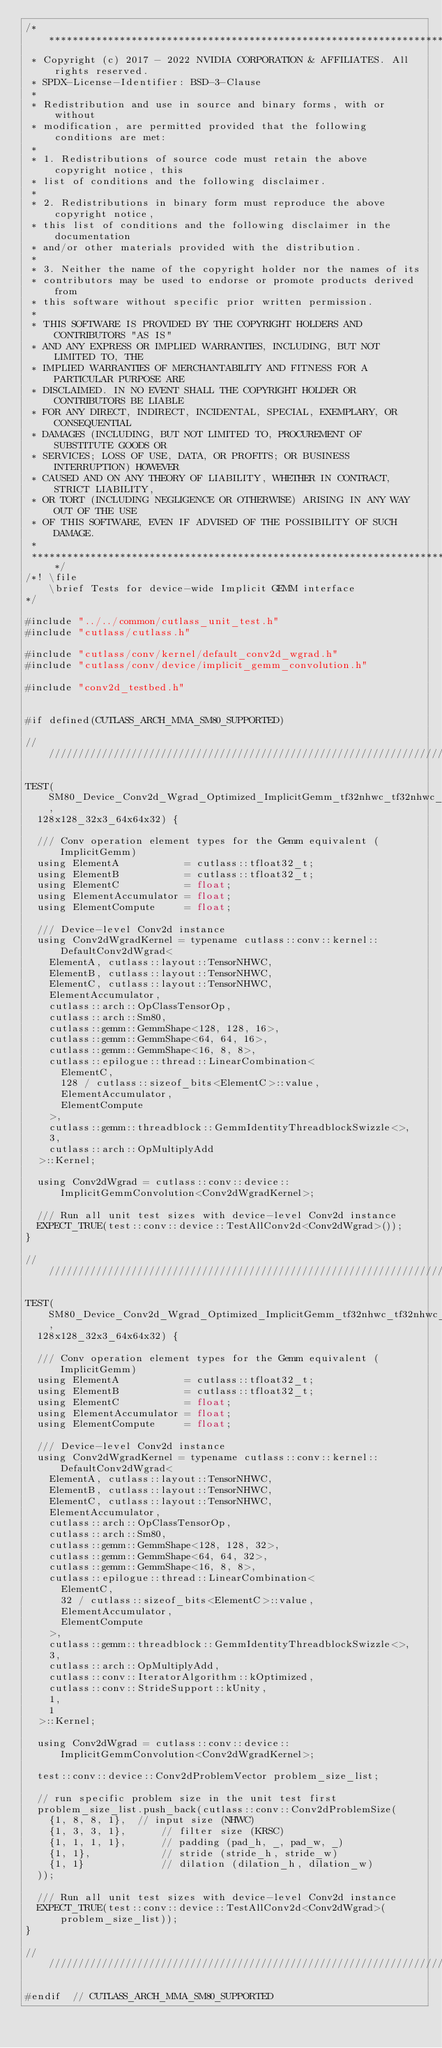Convert code to text. <code><loc_0><loc_0><loc_500><loc_500><_Cuda_>/***************************************************************************************************
 * Copyright (c) 2017 - 2022 NVIDIA CORPORATION & AFFILIATES. All rights reserved.
 * SPDX-License-Identifier: BSD-3-Clause
 *
 * Redistribution and use in source and binary forms, with or without
 * modification, are permitted provided that the following conditions are met:
 *
 * 1. Redistributions of source code must retain the above copyright notice, this
 * list of conditions and the following disclaimer.
 *
 * 2. Redistributions in binary form must reproduce the above copyright notice,
 * this list of conditions and the following disclaimer in the documentation
 * and/or other materials provided with the distribution.
 *
 * 3. Neither the name of the copyright holder nor the names of its
 * contributors may be used to endorse or promote products derived from
 * this software without specific prior written permission.
 *
 * THIS SOFTWARE IS PROVIDED BY THE COPYRIGHT HOLDERS AND CONTRIBUTORS "AS IS"
 * AND ANY EXPRESS OR IMPLIED WARRANTIES, INCLUDING, BUT NOT LIMITED TO, THE
 * IMPLIED WARRANTIES OF MERCHANTABILITY AND FITNESS FOR A PARTICULAR PURPOSE ARE
 * DISCLAIMED. IN NO EVENT SHALL THE COPYRIGHT HOLDER OR CONTRIBUTORS BE LIABLE
 * FOR ANY DIRECT, INDIRECT, INCIDENTAL, SPECIAL, EXEMPLARY, OR CONSEQUENTIAL
 * DAMAGES (INCLUDING, BUT NOT LIMITED TO, PROCUREMENT OF SUBSTITUTE GOODS OR
 * SERVICES; LOSS OF USE, DATA, OR PROFITS; OR BUSINESS INTERRUPTION) HOWEVER
 * CAUSED AND ON ANY THEORY OF LIABILITY, WHETHER IN CONTRACT, STRICT LIABILITY,
 * OR TORT (INCLUDING NEGLIGENCE OR OTHERWISE) ARISING IN ANY WAY OUT OF THE USE
 * OF THIS SOFTWARE, EVEN IF ADVISED OF THE POSSIBILITY OF SUCH DAMAGE.
 *
 **************************************************************************************************/
/*! \file
    \brief Tests for device-wide Implicit GEMM interface
*/

#include "../../common/cutlass_unit_test.h"
#include "cutlass/cutlass.h"

#include "cutlass/conv/kernel/default_conv2d_wgrad.h"
#include "cutlass/conv/device/implicit_gemm_convolution.h"

#include "conv2d_testbed.h"


#if defined(CUTLASS_ARCH_MMA_SM80_SUPPORTED)

////////////////////////////////////////////////////////////////////////////////

TEST(SM80_Device_Conv2d_Wgrad_Optimized_ImplicitGemm_tf32nhwc_tf32nhwc_f32nhwc_tensor_op_f32,
  128x128_32x3_64x64x32) {

  /// Conv operation element types for the Gemm equivalent (ImplicitGemm)
  using ElementA           = cutlass::tfloat32_t;
  using ElementB           = cutlass::tfloat32_t;
  using ElementC           = float;
  using ElementAccumulator = float;
  using ElementCompute     = float;

  /// Device-level Conv2d instance
  using Conv2dWgradKernel = typename cutlass::conv::kernel::DefaultConv2dWgrad<
    ElementA, cutlass::layout::TensorNHWC,
    ElementB, cutlass::layout::TensorNHWC,
    ElementC, cutlass::layout::TensorNHWC,
    ElementAccumulator,
    cutlass::arch::OpClassTensorOp,
    cutlass::arch::Sm80,
    cutlass::gemm::GemmShape<128, 128, 16>,
    cutlass::gemm::GemmShape<64, 64, 16>,
    cutlass::gemm::GemmShape<16, 8, 8>,
    cutlass::epilogue::thread::LinearCombination<
      ElementC,
      128 / cutlass::sizeof_bits<ElementC>::value,
      ElementAccumulator,
      ElementCompute
    >,
    cutlass::gemm::threadblock::GemmIdentityThreadblockSwizzle<>,
    3,
    cutlass::arch::OpMultiplyAdd
  >::Kernel;

  using Conv2dWgrad = cutlass::conv::device::ImplicitGemmConvolution<Conv2dWgradKernel>;

  /// Run all unit test sizes with device-level Conv2d instance
  EXPECT_TRUE(test::conv::device::TestAllConv2d<Conv2dWgrad>());
}

////////////////////////////////////////////////////////////////////////////////

TEST(SM80_Device_Conv2d_Wgrad_Optimized_ImplicitGemm_tf32nhwc_tf32nhwc_f32nhwc_tensor_op_f32_align1,
  128x128_32x3_64x64x32) {

  /// Conv operation element types for the Gemm equivalent (ImplicitGemm)
  using ElementA           = cutlass::tfloat32_t;
  using ElementB           = cutlass::tfloat32_t;
  using ElementC           = float;
  using ElementAccumulator = float;
  using ElementCompute     = float;

  /// Device-level Conv2d instance
  using Conv2dWgradKernel = typename cutlass::conv::kernel::DefaultConv2dWgrad<
    ElementA, cutlass::layout::TensorNHWC,
    ElementB, cutlass::layout::TensorNHWC,
    ElementC, cutlass::layout::TensorNHWC,
    ElementAccumulator,
    cutlass::arch::OpClassTensorOp,
    cutlass::arch::Sm80,
    cutlass::gemm::GemmShape<128, 128, 32>,
    cutlass::gemm::GemmShape<64, 64, 32>,
    cutlass::gemm::GemmShape<16, 8, 8>,
    cutlass::epilogue::thread::LinearCombination<
      ElementC,
      32 / cutlass::sizeof_bits<ElementC>::value,
      ElementAccumulator,
      ElementCompute
    >,
    cutlass::gemm::threadblock::GemmIdentityThreadblockSwizzle<>,
    3,
    cutlass::arch::OpMultiplyAdd,
    cutlass::conv::IteratorAlgorithm::kOptimized,
    cutlass::conv::StrideSupport::kUnity,
    1,
    1    
  >::Kernel;

  using Conv2dWgrad = cutlass::conv::device::ImplicitGemmConvolution<Conv2dWgradKernel>;

  test::conv::device::Conv2dProblemVector problem_size_list;

  // run specific problem size in the unit test first
  problem_size_list.push_back(cutlass::conv::Conv2dProblemSize(
    {1, 8, 8, 1},  // input size (NHWC)
    {1, 3, 3, 1},      // filter size (KRSC)
    {1, 1, 1, 1},      // padding (pad_h, _, pad_w, _)
    {1, 1},            // stride (stride_h, stride_w)
    {1, 1}             // dilation (dilation_h, dilation_w)
  ));

  /// Run all unit test sizes with device-level Conv2d instance
  EXPECT_TRUE(test::conv::device::TestAllConv2d<Conv2dWgrad>(problem_size_list));
}

////////////////////////////////////////////////////////////////////////////////

#endif  // CUTLASS_ARCH_MMA_SM80_SUPPORTED
</code> 